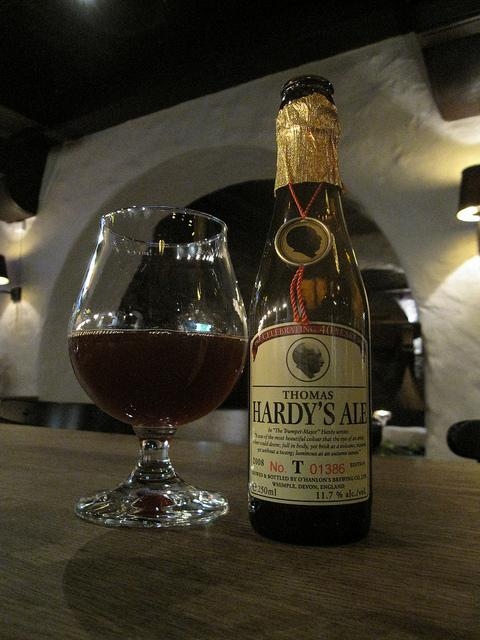What celebrity has a similar name to the name on the bottle?

Choices:
A) charlize theron
B) gaite jansen
C) tom hardy
D) cillian murphy tom hardy 